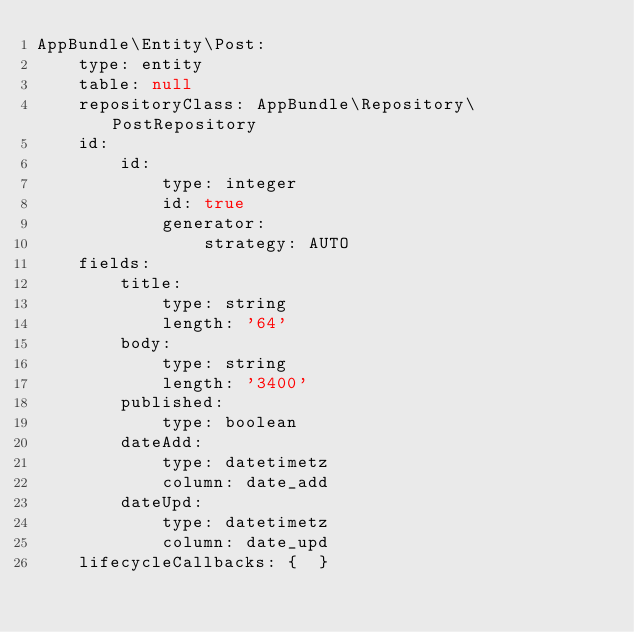Convert code to text. <code><loc_0><loc_0><loc_500><loc_500><_YAML_>AppBundle\Entity\Post:
    type: entity
    table: null
    repositoryClass: AppBundle\Repository\PostRepository
    id:
        id:
            type: integer
            id: true
            generator:
                strategy: AUTO
    fields:
        title:
            type: string
            length: '64'
        body:
            type: string
            length: '3400'
        published:
            type: boolean
        dateAdd:
            type: datetimetz
            column: date_add
        dateUpd:
            type: datetimetz
            column: date_upd
    lifecycleCallbacks: {  }
</code> 